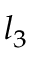Convert formula to latex. <formula><loc_0><loc_0><loc_500><loc_500>l _ { 3 }</formula> 